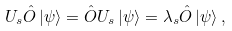<formula> <loc_0><loc_0><loc_500><loc_500>U _ { s } \hat { O } \left | \psi \right \rangle = \hat { O } U _ { s } \left | \psi \right \rangle = \lambda _ { s } \hat { O } \left | \psi \right \rangle ,</formula> 